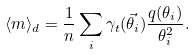Convert formula to latex. <formula><loc_0><loc_0><loc_500><loc_500>\langle m \rangle _ { d } = \frac { 1 } { n } \sum _ { i } \gamma _ { t } ( \vec { \theta } _ { i } ) \frac { q ( \theta _ { i } ) } { \theta _ { i } ^ { 2 } } .</formula> 